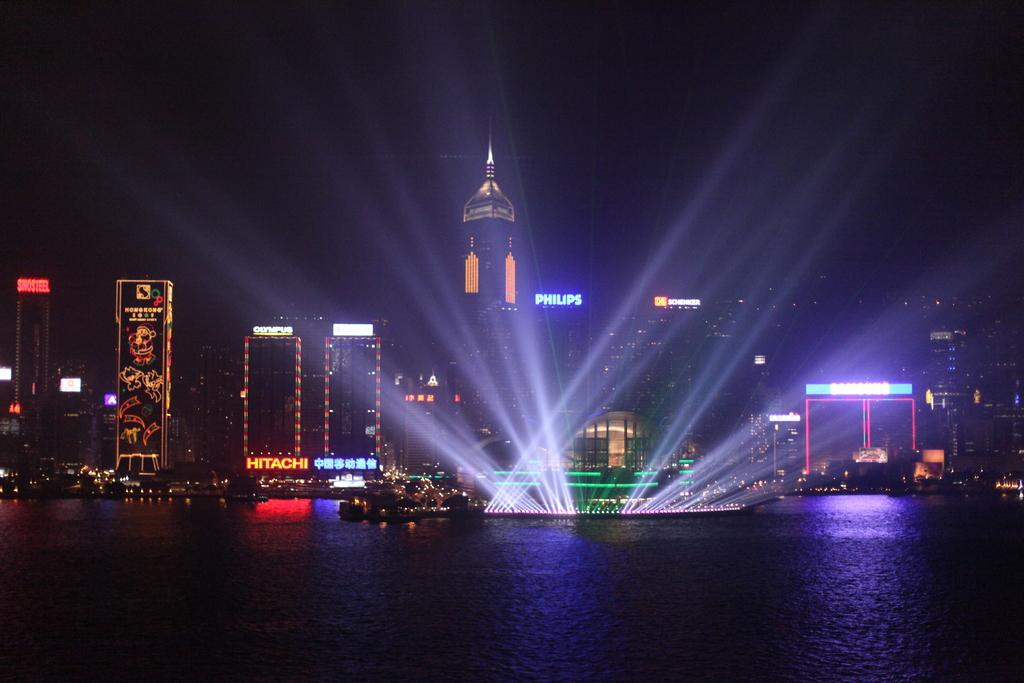What is at the bottom of the image? There is water at the bottom of the image. What can be seen behind the water? There are buildings behind the water. What feature do the buildings have? The buildings have lights. What else can be seen on the buildings? The buildings have name boards. What type of fruit is being used as a caption for the image? There is no fruit being used as a caption for the image. The image does not have a caption, and fruit is not mentioned in the provided facts. 